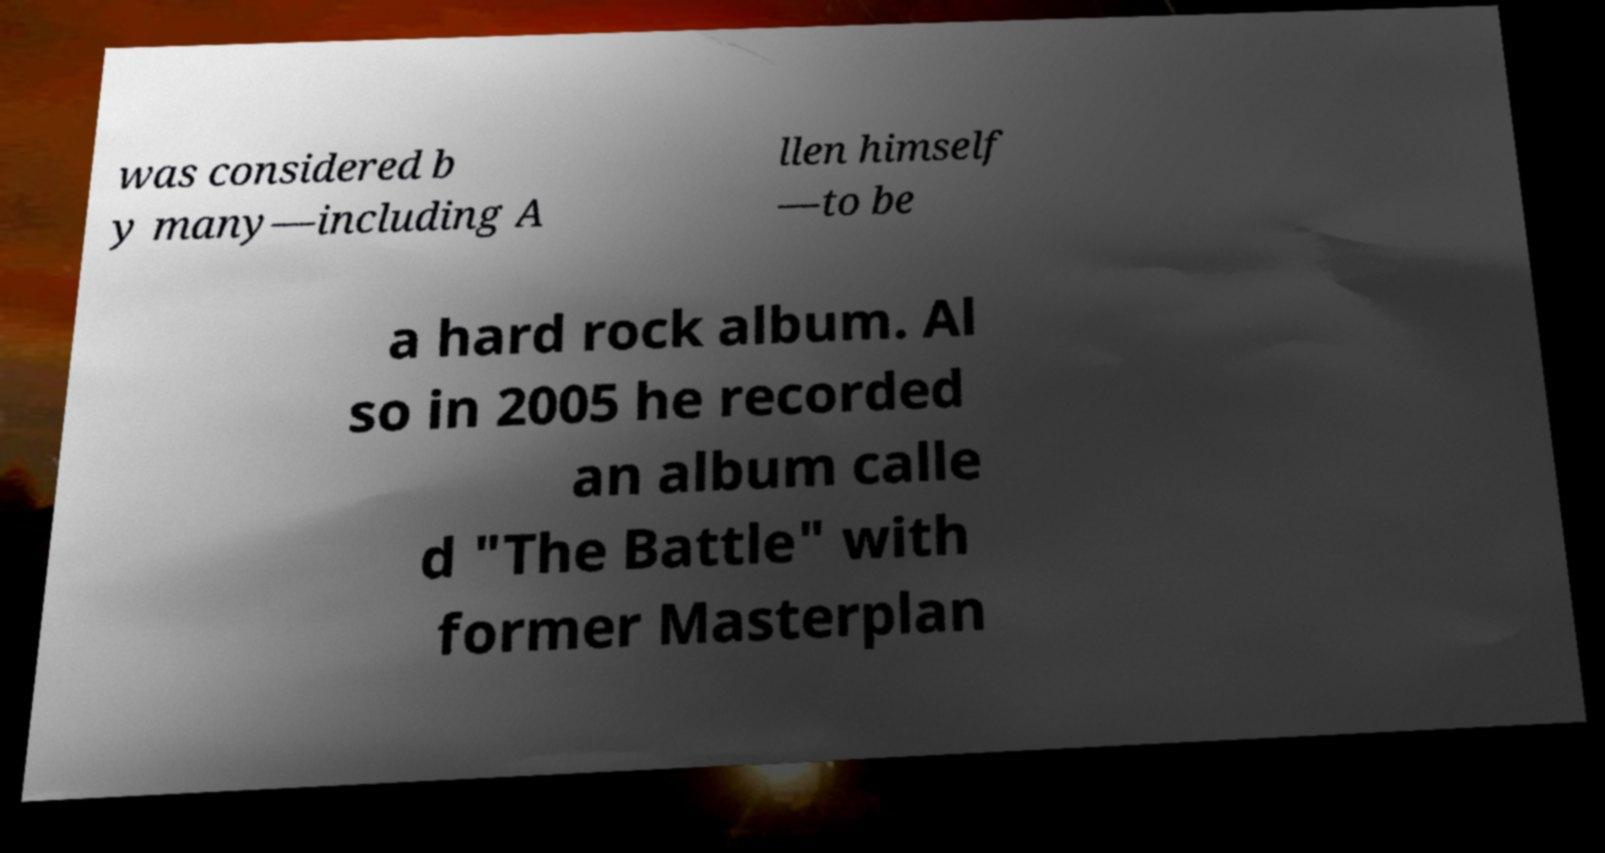What messages or text are displayed in this image? I need them in a readable, typed format. was considered b y many—including A llen himself —to be a hard rock album. Al so in 2005 he recorded an album calle d "The Battle" with former Masterplan 